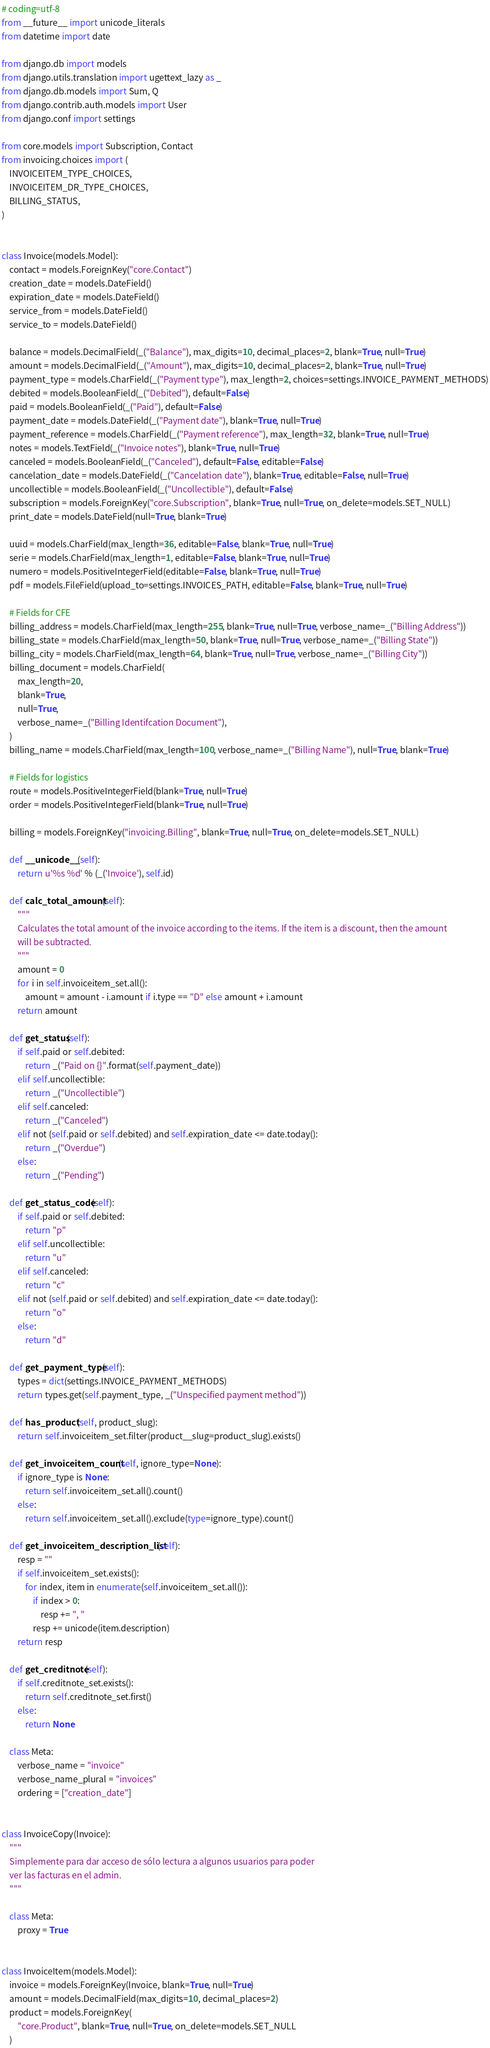<code> <loc_0><loc_0><loc_500><loc_500><_Python_># coding=utf-8
from __future__ import unicode_literals
from datetime import date

from django.db import models
from django.utils.translation import ugettext_lazy as _
from django.db.models import Sum, Q
from django.contrib.auth.models import User
from django.conf import settings

from core.models import Subscription, Contact
from invoicing.choices import (
    INVOICEITEM_TYPE_CHOICES,
    INVOICEITEM_DR_TYPE_CHOICES,
    BILLING_STATUS,
)


class Invoice(models.Model):
    contact = models.ForeignKey("core.Contact")
    creation_date = models.DateField()
    expiration_date = models.DateField()
    service_from = models.DateField()
    service_to = models.DateField()

    balance = models.DecimalField(_("Balance"), max_digits=10, decimal_places=2, blank=True, null=True)
    amount = models.DecimalField(_("Amount"), max_digits=10, decimal_places=2, blank=True, null=True)
    payment_type = models.CharField(_("Payment type"), max_length=2, choices=settings.INVOICE_PAYMENT_METHODS)
    debited = models.BooleanField(_("Debited"), default=False)
    paid = models.BooleanField(_("Paid"), default=False)
    payment_date = models.DateField(_("Payment date"), blank=True, null=True)
    payment_reference = models.CharField(_("Payment reference"), max_length=32, blank=True, null=True)
    notes = models.TextField(_("Invoice notes"), blank=True, null=True)
    canceled = models.BooleanField(_("Canceled"), default=False, editable=False)
    cancelation_date = models.DateField(_("Cancelation date"), blank=True, editable=False, null=True)
    uncollectible = models.BooleanField(_("Uncollectible"), default=False)
    subscription = models.ForeignKey("core.Subscription", blank=True, null=True, on_delete=models.SET_NULL)
    print_date = models.DateField(null=True, blank=True)

    uuid = models.CharField(max_length=36, editable=False, blank=True, null=True)
    serie = models.CharField(max_length=1, editable=False, blank=True, null=True)
    numero = models.PositiveIntegerField(editable=False, blank=True, null=True)
    pdf = models.FileField(upload_to=settings.INVOICES_PATH, editable=False, blank=True, null=True)

    # Fields for CFE
    billing_address = models.CharField(max_length=255, blank=True, null=True, verbose_name=_("Billing Address"))
    billing_state = models.CharField(max_length=50, blank=True, null=True, verbose_name=_("Billing State"))
    billing_city = models.CharField(max_length=64, blank=True, null=True, verbose_name=_("Billing City"))
    billing_document = models.CharField(
        max_length=20,
        blank=True,
        null=True,
        verbose_name=_("Billing Identifcation Document"),
    )
    billing_name = models.CharField(max_length=100, verbose_name=_("Billing Name"), null=True, blank=True)

    # Fields for logistics
    route = models.PositiveIntegerField(blank=True, null=True)
    order = models.PositiveIntegerField(blank=True, null=True)

    billing = models.ForeignKey("invoicing.Billing", blank=True, null=True, on_delete=models.SET_NULL)

    def __unicode__(self):
        return u'%s %d' % (_('Invoice'), self.id)

    def calc_total_amount(self):
        """
        Calculates the total amount of the invoice according to the items. If the item is a discount, then the amount
        will be subtracted.
        """
        amount = 0
        for i in self.invoiceitem_set.all():
            amount = amount - i.amount if i.type == "D" else amount + i.amount
        return amount

    def get_status(self):
        if self.paid or self.debited:
            return _("Paid on {}".format(self.payment_date))
        elif self.uncollectible:
            return _("Uncollectible")
        elif self.canceled:
            return _("Canceled")
        elif not (self.paid or self.debited) and self.expiration_date <= date.today():
            return _("Overdue")
        else:
            return _("Pending")

    def get_status_code(self):
        if self.paid or self.debited:
            return "p"
        elif self.uncollectible:
            return "u"
        elif self.canceled:
            return "c"
        elif not (self.paid or self.debited) and self.expiration_date <= date.today():
            return "o"
        else:
            return "d"

    def get_payment_type(self):
        types = dict(settings.INVOICE_PAYMENT_METHODS)
        return types.get(self.payment_type, _("Unspecified payment method"))

    def has_product(self, product_slug):
        return self.invoiceitem_set.filter(product__slug=product_slug).exists()

    def get_invoiceitem_count(self, ignore_type=None):
        if ignore_type is None:
            return self.invoiceitem_set.all().count()
        else:
            return self.invoiceitem_set.all().exclude(type=ignore_type).count()

    def get_invoiceitem_description_list(self):
        resp = ""
        if self.invoiceitem_set.exists():
            for index, item in enumerate(self.invoiceitem_set.all()):
                if index > 0:
                    resp += ", "
                resp += unicode(item.description)
        return resp

    def get_creditnote(self):
        if self.creditnote_set.exists():
            return self.creditnote_set.first()
        else:
            return None

    class Meta:
        verbose_name = "invoice"
        verbose_name_plural = "invoices"
        ordering = ["creation_date"]


class InvoiceCopy(Invoice):
    """
    Simplemente para dar acceso de sólo lectura a algunos usuarios para poder
    ver las facturas en el admin.
    """

    class Meta:
        proxy = True


class InvoiceItem(models.Model):
    invoice = models.ForeignKey(Invoice, blank=True, null=True)
    amount = models.DecimalField(max_digits=10, decimal_places=2)
    product = models.ForeignKey(
        "core.Product", blank=True, null=True, on_delete=models.SET_NULL
    )</code> 